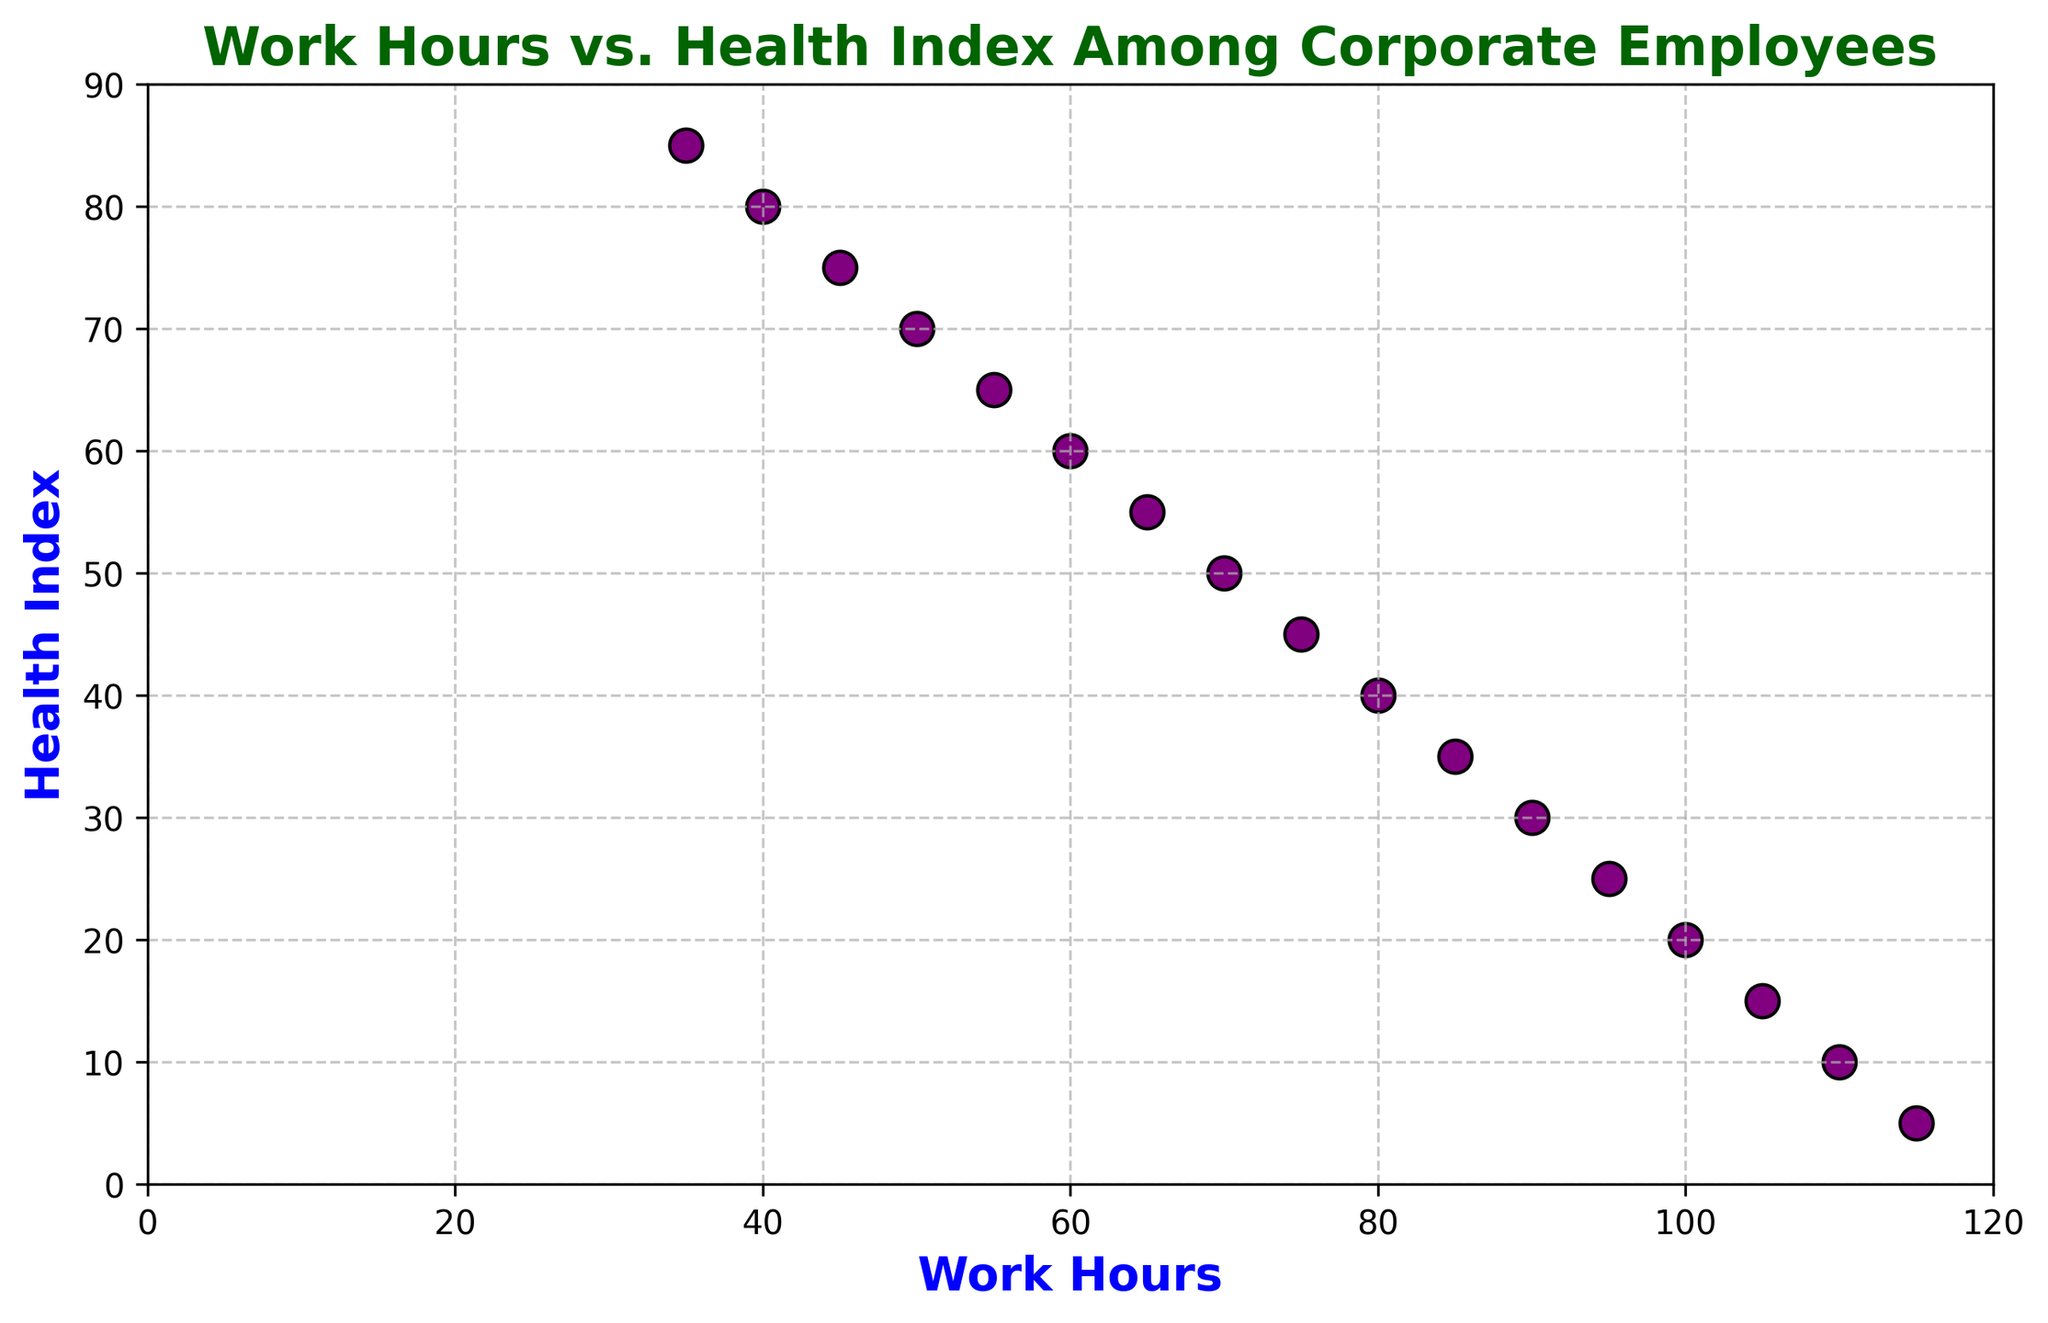What is the general trend observed between Work Hours and Health Index? The scatter plot visually shows that as the work hours increase, the health index tends to decrease.
Answer: Decreasing Which data point has the highest Health Index, and what are its Work Hours? By looking at the highest position on the Health Index axis, you can see that the point (35, 85) has the highest Health Index.
Answer: (35, 85) Between Work Hours 60 and 90, which work hour has the lowest Health Index? Observing the points between 60 and 90 on the Work Hours axis, Work Hours 90 has the lowest Health Index of 30.
Answer: 90 Compare the Health Index values at 40 Work Hours and 80 Work Hours. Which is higher? Looking at the specific points for 40 and 80 Work Hours, the Health Index at 40 Work Hours is 80, whereas at 80 Work Hours it is 40. Hence, 40 Work Hours has a higher Health Index.
Answer: 40 Work Hours Is the Health Index at 50 Work Hours higher than that at 105 Work Hours? By referencing the plot, the Health Index at 50 Work Hours is 70, and at 105 Work Hours it is 15. Thus, the Health Index at 50 Work Hours is higher.
Answer: Yes What difference in Health Index is observed between Work Hours 45 and 65? By subtracting the Health Index at 65 Work Hours (55) from that at 45 Work Hours (75), the difference is 75 - 55 = 20.
Answer: 20 What is the average Health Index for Work Hours 35, 55, and 75? Summing the Health Indices for 35, 55, and 75 Work Hours (85, 65, and 45, respectively) gives 85 + 65 + 45 = 195. The average is 195 / 3 = 65.
Answer: 65 What is the sum of the Health Indices for Work Hours 35, 70, and 105? Adding the Health Indices for 35, 70, and 105 Work Hours (85, 50, and 15, respectively) results in 85 + 50 + 15 = 150.
Answer: 150 Which work hour marks the point where the Health Index first drops below 50? Observing the work hours increment, the Health Index first drops below 50 at 70 Work Hours, where the Health Index is 50.
Answer: 70 If you need to maintain a Health Index of at least 60, should you work more than 60 hours? Based on the plot, the Health Index is 60 at 60 Work Hours and drops below 60 for any work hours greater than 60. Therefore, you should not work more than 60 hours if you want to maintain a Health Index of at least 60.
Answer: No 